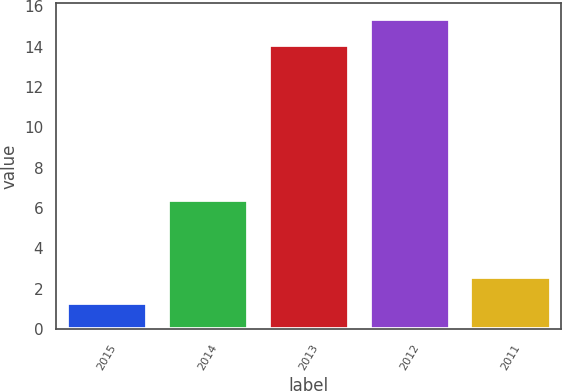<chart> <loc_0><loc_0><loc_500><loc_500><bar_chart><fcel>2015<fcel>2014<fcel>2013<fcel>2012<fcel>2011<nl><fcel>1.3<fcel>6.4<fcel>14.1<fcel>15.38<fcel>2.58<nl></chart> 